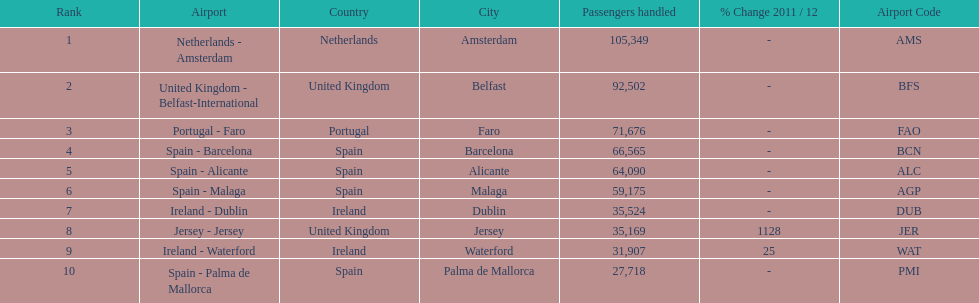How many passengers were handled in an airport in spain? 217,548. 